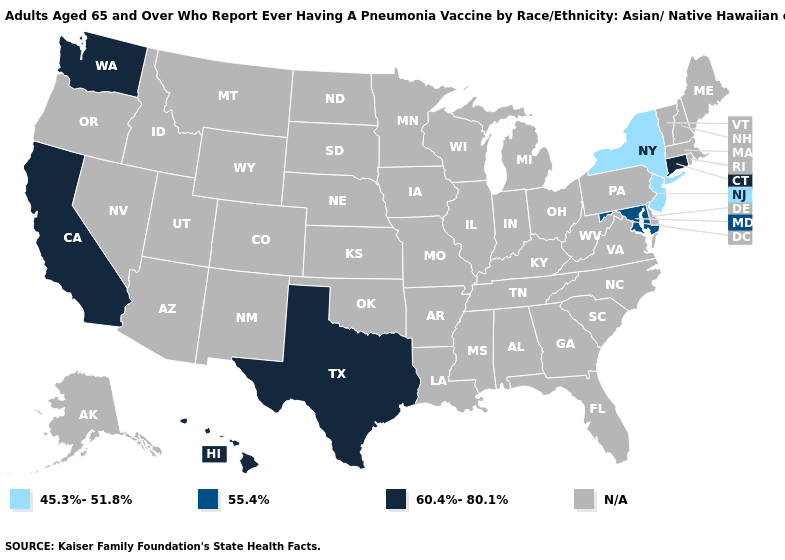Does New York have the highest value in the USA?
Give a very brief answer. No. What is the highest value in the Northeast ?
Concise answer only. 60.4%-80.1%. Name the states that have a value in the range 60.4%-80.1%?
Keep it brief. California, Connecticut, Hawaii, Texas, Washington. Does the first symbol in the legend represent the smallest category?
Keep it brief. Yes. How many symbols are there in the legend?
Short answer required. 4. Name the states that have a value in the range 45.3%-51.8%?
Answer briefly. New Jersey, New York. Does the map have missing data?
Answer briefly. Yes. Which states have the highest value in the USA?
Keep it brief. California, Connecticut, Hawaii, Texas, Washington. Name the states that have a value in the range 55.4%?
Keep it brief. Maryland. 